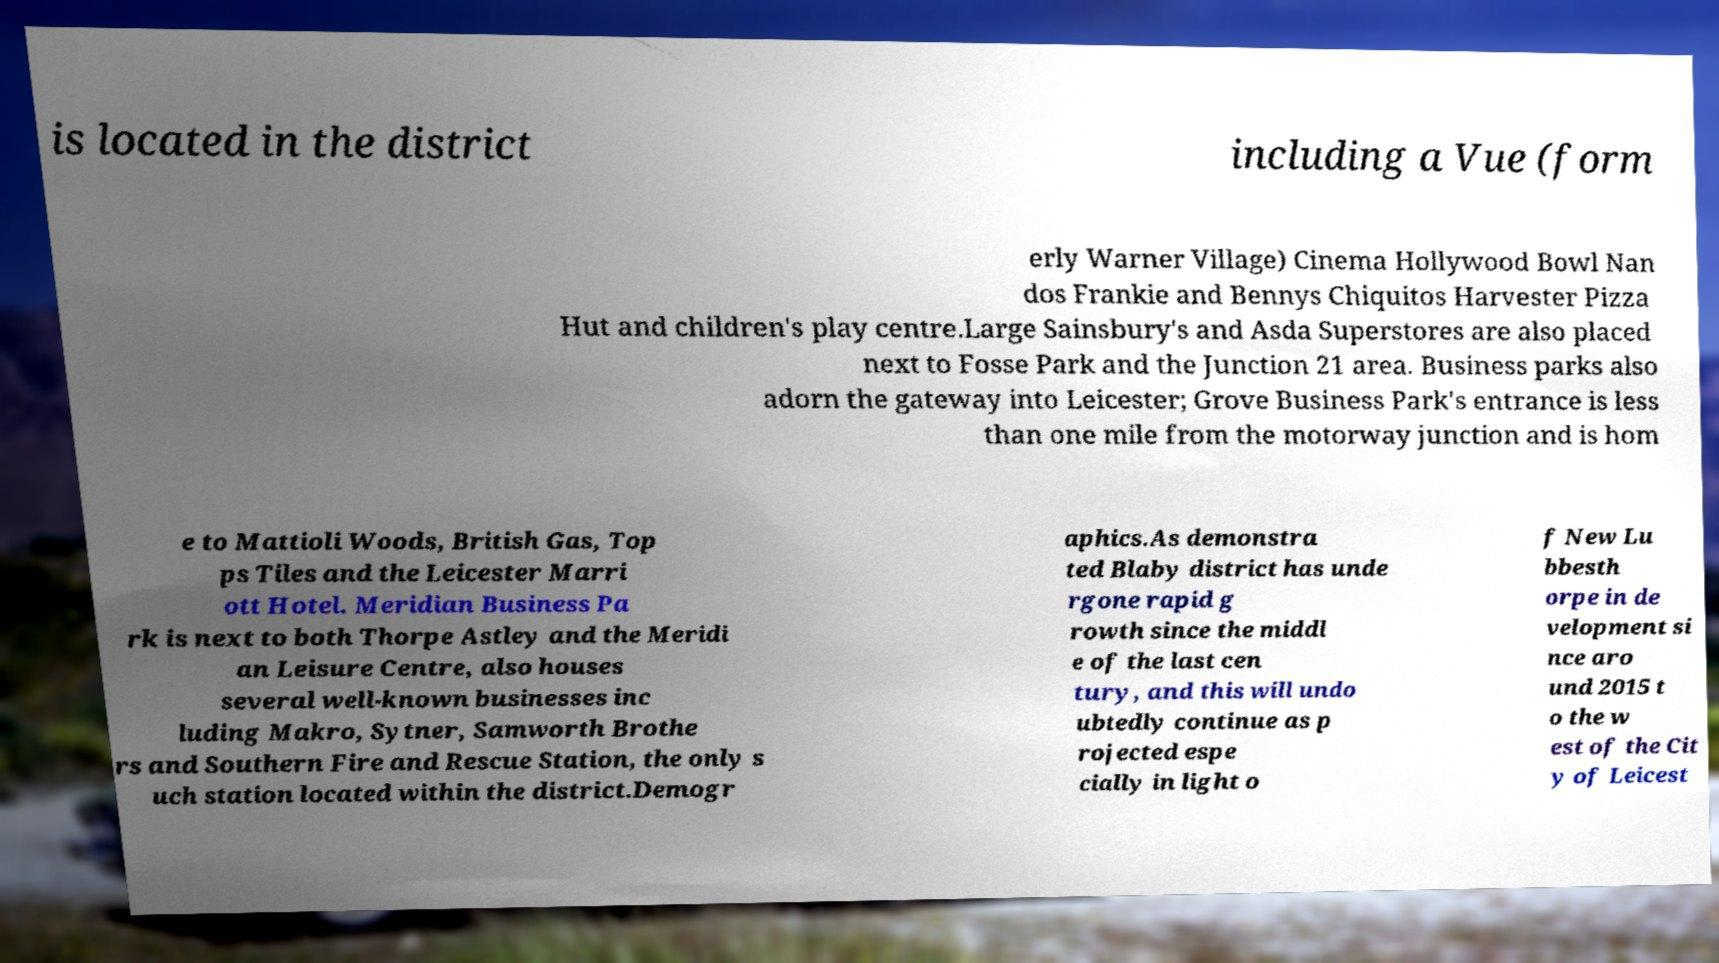Can you read and provide the text displayed in the image?This photo seems to have some interesting text. Can you extract and type it out for me? is located in the district including a Vue (form erly Warner Village) Cinema Hollywood Bowl Nan dos Frankie and Bennys Chiquitos Harvester Pizza Hut and children's play centre.Large Sainsbury's and Asda Superstores are also placed next to Fosse Park and the Junction 21 area. Business parks also adorn the gateway into Leicester; Grove Business Park's entrance is less than one mile from the motorway junction and is hom e to Mattioli Woods, British Gas, Top ps Tiles and the Leicester Marri ott Hotel. Meridian Business Pa rk is next to both Thorpe Astley and the Meridi an Leisure Centre, also houses several well-known businesses inc luding Makro, Sytner, Samworth Brothe rs and Southern Fire and Rescue Station, the only s uch station located within the district.Demogr aphics.As demonstra ted Blaby district has unde rgone rapid g rowth since the middl e of the last cen tury, and this will undo ubtedly continue as p rojected espe cially in light o f New Lu bbesth orpe in de velopment si nce aro und 2015 t o the w est of the Cit y of Leicest 